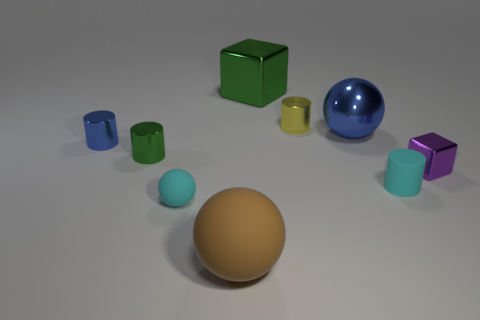Subtract all small shiny cylinders. How many cylinders are left? 1 Add 1 purple rubber blocks. How many objects exist? 10 Subtract all cyan balls. How many balls are left? 2 Add 8 small blue cylinders. How many small blue cylinders exist? 9 Subtract 1 blue cylinders. How many objects are left? 8 Subtract all blocks. How many objects are left? 7 Subtract 2 spheres. How many spheres are left? 1 Subtract all brown balls. Subtract all purple cubes. How many balls are left? 2 Subtract all tiny purple blocks. Subtract all red matte things. How many objects are left? 8 Add 1 matte balls. How many matte balls are left? 3 